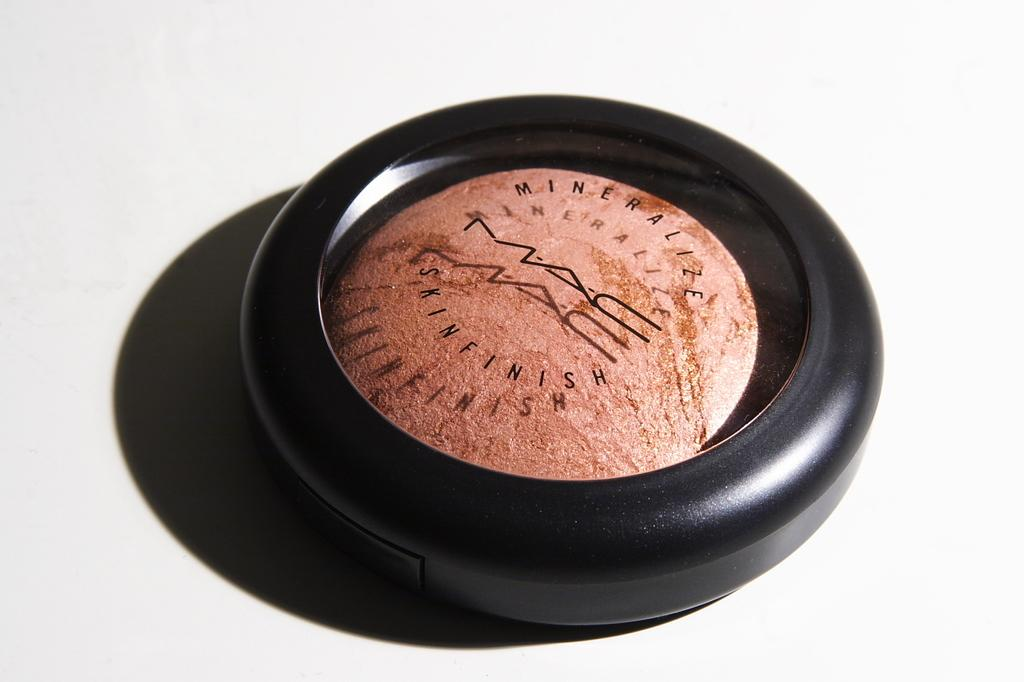Provide a one-sentence caption for the provided image. A fancy MAC skinfinish product displayed on a white background. 